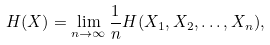Convert formula to latex. <formula><loc_0><loc_0><loc_500><loc_500>H ( X ) = \lim _ { n \to \infty } \frac { 1 } { n } H ( X _ { 1 } , X _ { 2 } , \dots , X _ { n } ) ,</formula> 